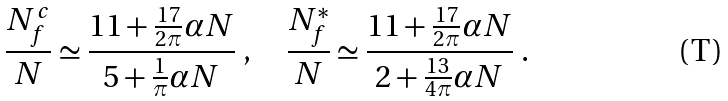Convert formula to latex. <formula><loc_0><loc_0><loc_500><loc_500>\frac { N _ { f } ^ { c } } { N } \simeq \frac { 1 1 + \frac { 1 7 } { 2 \pi } \alpha N } { 5 + \frac { 1 } { \pi } \alpha N } \ , \quad \frac { N _ { f } ^ { \ast } } { N } \simeq \frac { 1 1 + \frac { 1 7 } { 2 \pi } \alpha N } { 2 + \frac { 1 3 } { 4 \pi } \alpha N } \ .</formula> 